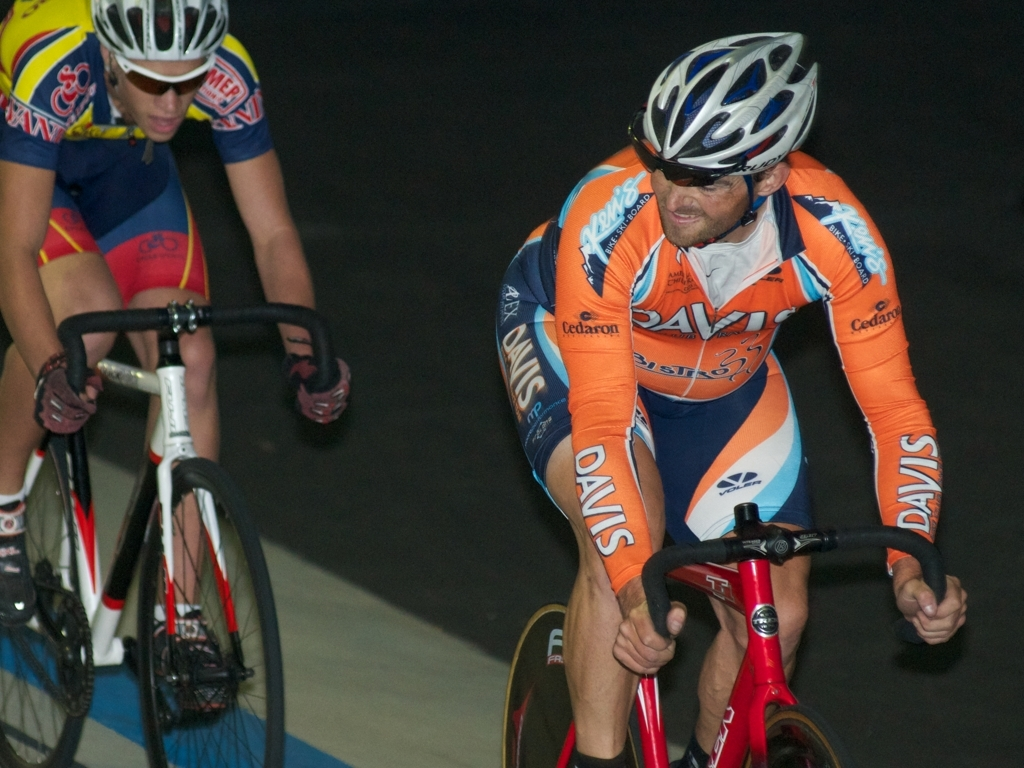How are the colors in this image?
A. The colors in this image are dull.
B. The colors in this image are vibrant.
C. The colors in this image are faded.
Answer with the option's letter from the given choices directly.
 B. 